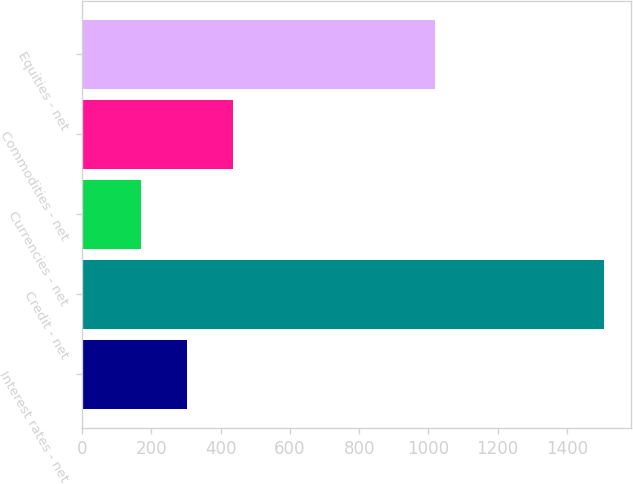Convert chart. <chart><loc_0><loc_0><loc_500><loc_500><bar_chart><fcel>Interest rates - net<fcel>Credit - net<fcel>Currencies - net<fcel>Commodities - net<fcel>Equities - net<nl><fcel>302.9<fcel>1508<fcel>169<fcel>436.8<fcel>1020<nl></chart> 